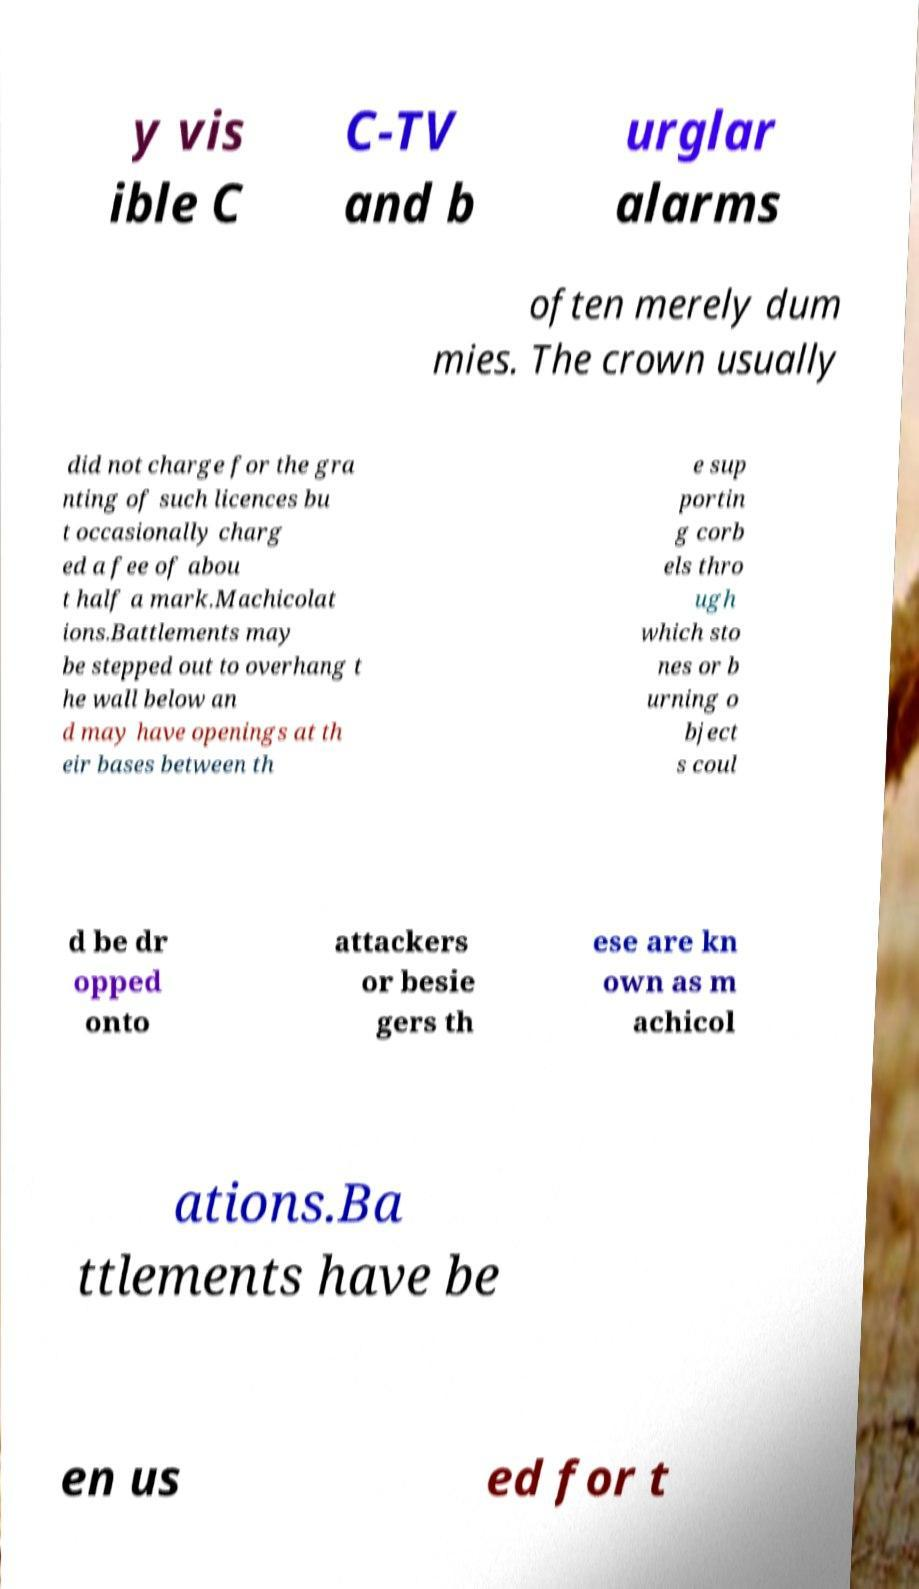Please identify and transcribe the text found in this image. y vis ible C C-TV and b urglar alarms often merely dum mies. The crown usually did not charge for the gra nting of such licences bu t occasionally charg ed a fee of abou t half a mark.Machicolat ions.Battlements may be stepped out to overhang t he wall below an d may have openings at th eir bases between th e sup portin g corb els thro ugh which sto nes or b urning o bject s coul d be dr opped onto attackers or besie gers th ese are kn own as m achicol ations.Ba ttlements have be en us ed for t 